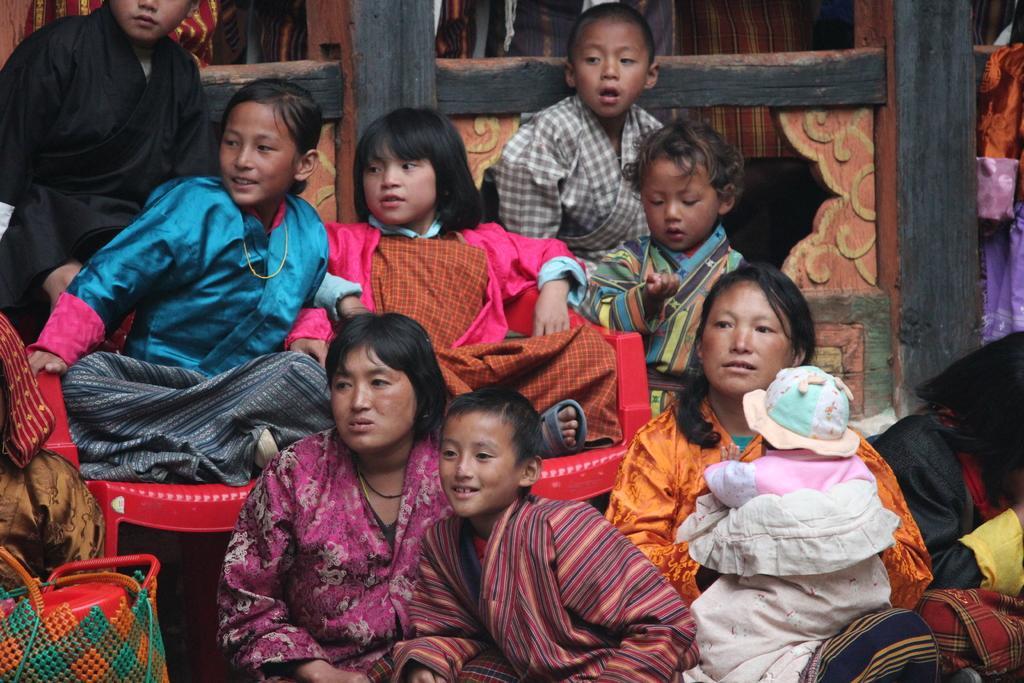How would you summarize this image in a sentence or two? In the center of the image we can see people sitting and there are babies. We can see chairs. In the background there is a fence. 